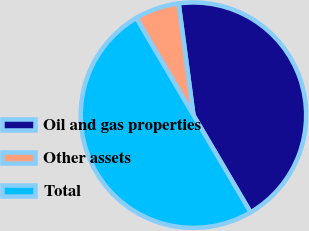Convert chart. <chart><loc_0><loc_0><loc_500><loc_500><pie_chart><fcel>Oil and gas properties<fcel>Other assets<fcel>Total<nl><fcel>43.63%<fcel>6.37%<fcel>50.0%<nl></chart> 